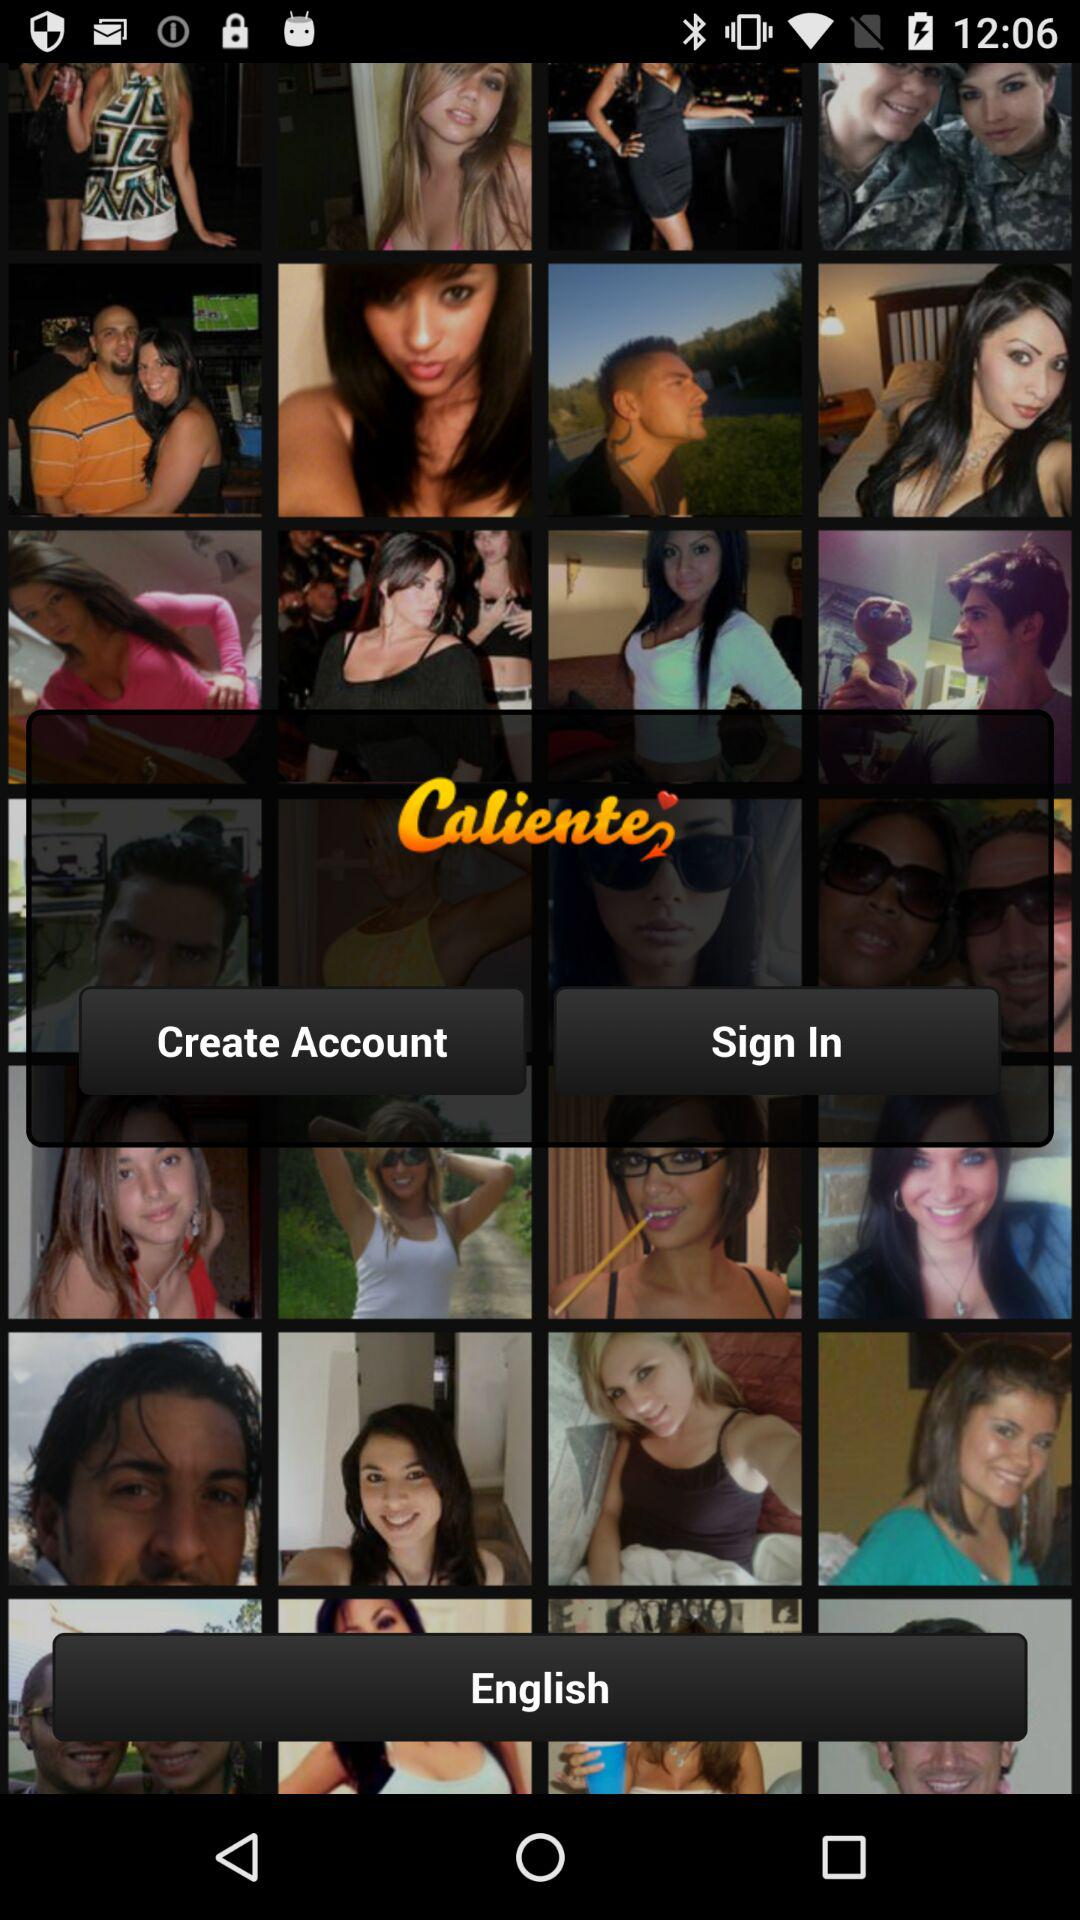What is the app name? The app name is "Caliente". 